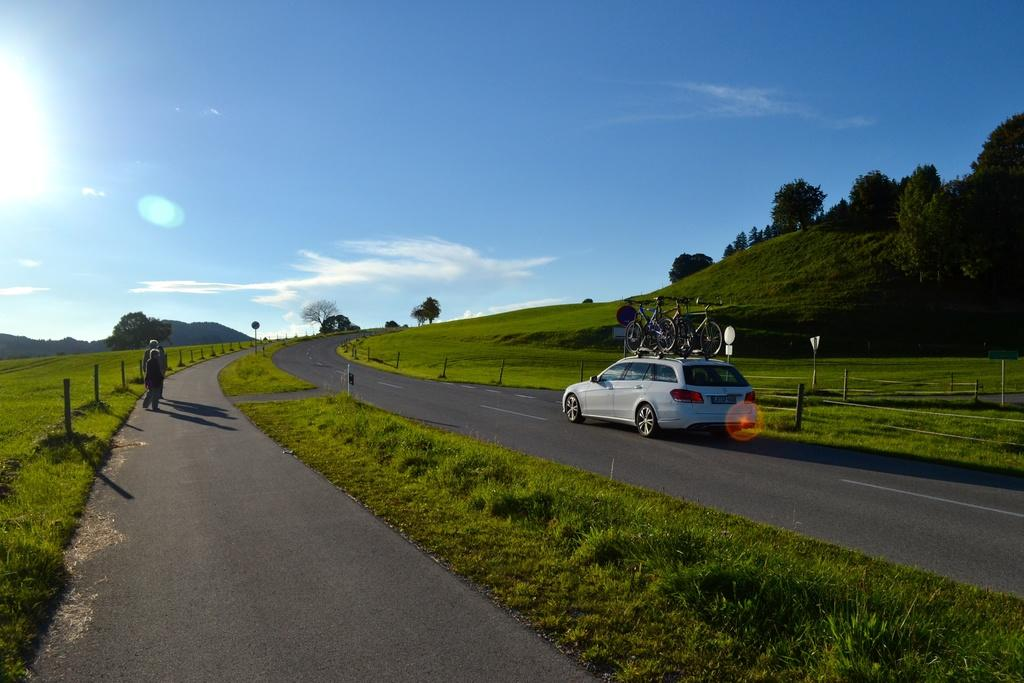Who or what is located on the left side of the image? There are people on the left side of the image. What type of pathway is visible in the image? There is a roadway in the image. What mode of transportation can be seen in the image? There is a car in the image. What is the car carrying in the image? The car is carrying bicycles. Can you tell me what hobbies the monkey on the right side of the image is interested in? There is no monkey present in the image, so we cannot determine any hobbies. Is there a lake visible in the image? No, there is no lake visible in the image. 